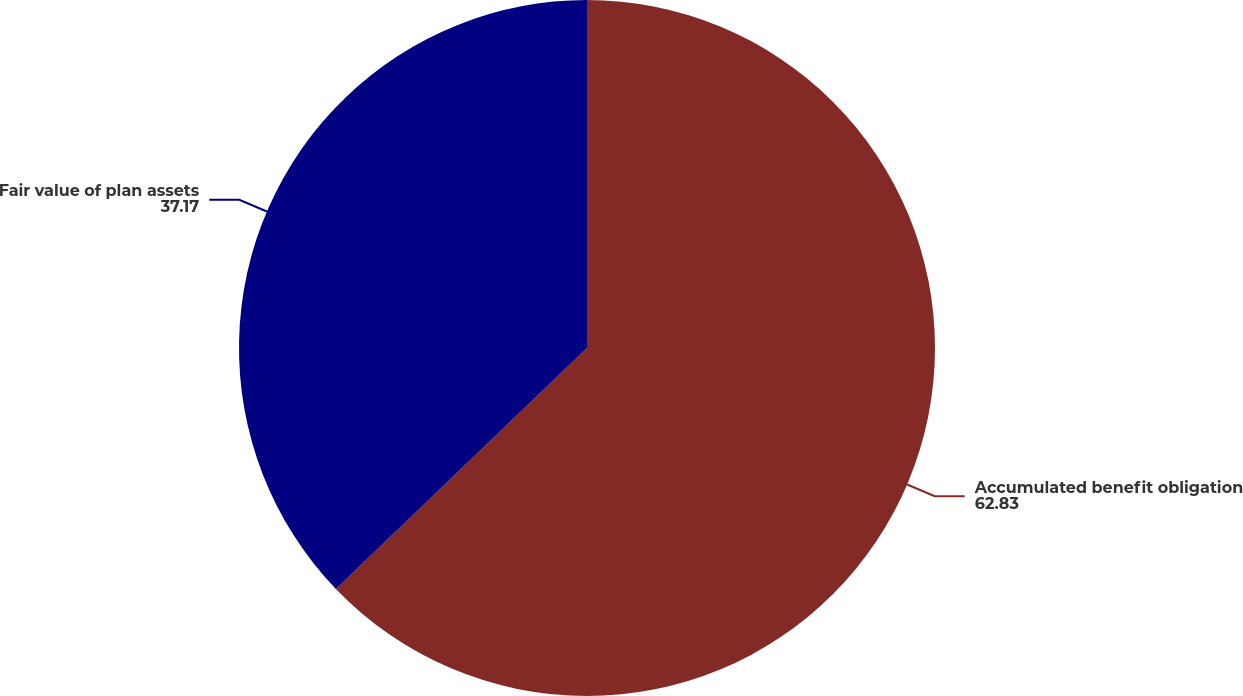Convert chart to OTSL. <chart><loc_0><loc_0><loc_500><loc_500><pie_chart><fcel>Accumulated benefit obligation<fcel>Fair value of plan assets<nl><fcel>62.83%<fcel>37.17%<nl></chart> 